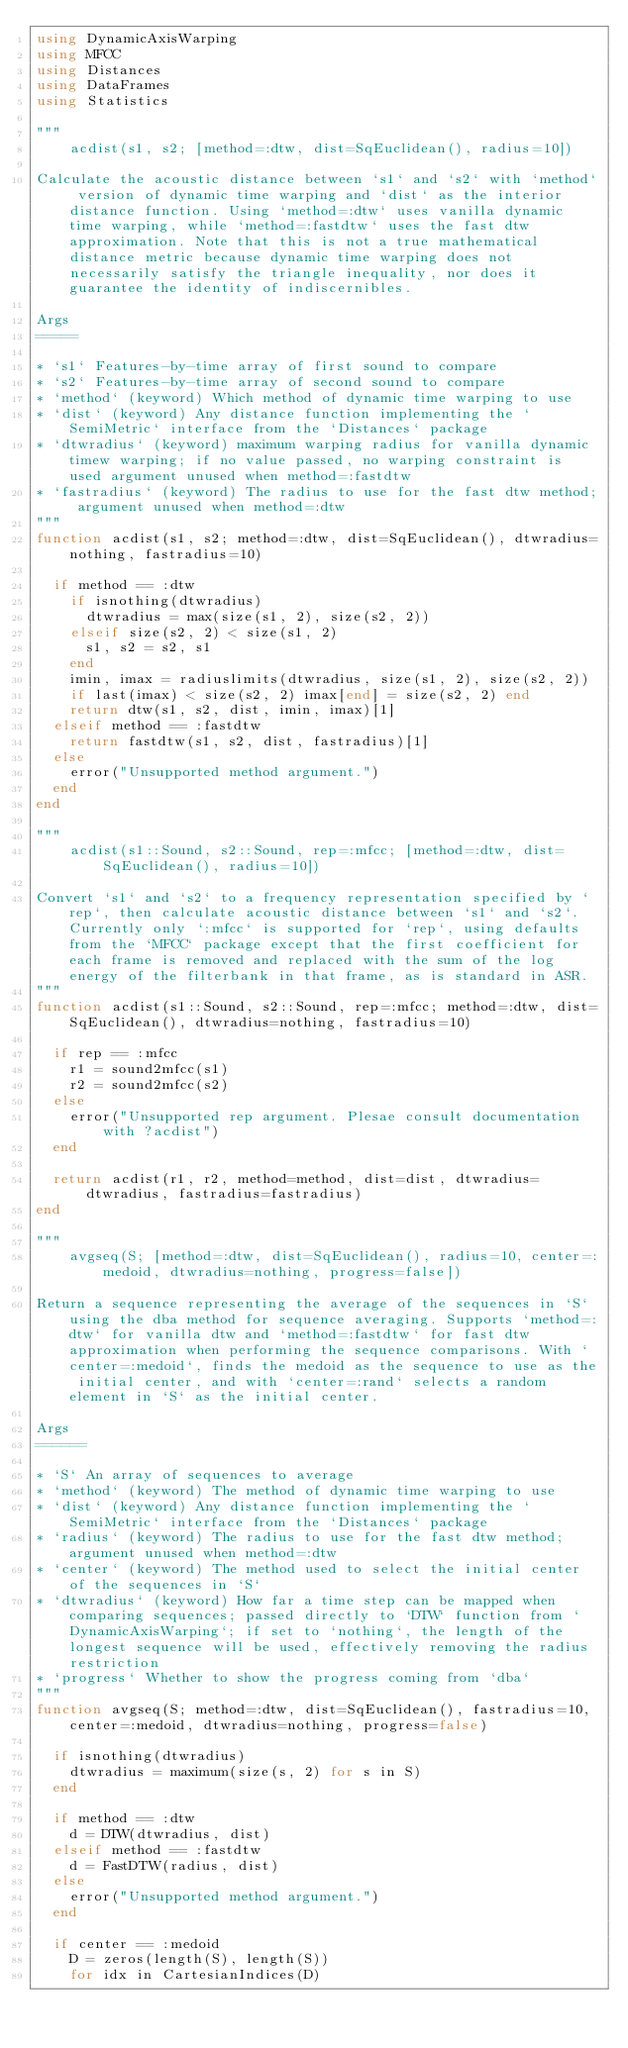<code> <loc_0><loc_0><loc_500><loc_500><_Julia_>using DynamicAxisWarping
using MFCC
using Distances
using DataFrames
using Statistics

"""
    acdist(s1, s2; [method=:dtw, dist=SqEuclidean(), radius=10])

Calculate the acoustic distance between `s1` and `s2` with `method` version of dynamic time warping and `dist` as the interior distance function. Using `method=:dtw` uses vanilla dynamic time warping, while `method=:fastdtw` uses the fast dtw approximation. Note that this is not a true mathematical distance metric because dynamic time warping does not necessarily satisfy the triangle inequality, nor does it guarantee the identity of indiscernibles.

Args
=====

* `s1` Features-by-time array of first sound to compare
* `s2` Features-by-time array of second sound to compare
* `method` (keyword) Which method of dynamic time warping to use
* `dist` (keyword) Any distance function implementing the `SemiMetric` interface from the `Distances` package
* `dtwradius` (keyword) maximum warping radius for vanilla dynamic timew warping; if no value passed, no warping constraint is used argument unused when method=:fastdtw
* `fastradius` (keyword) The radius to use for the fast dtw method; argument unused when method=:dtw
"""
function acdist(s1, s2; method=:dtw, dist=SqEuclidean(), dtwradius=nothing, fastradius=10)
  
  if method == :dtw
    if isnothing(dtwradius)
      dtwradius = max(size(s1, 2), size(s2, 2))
    elseif size(s2, 2) < size(s1, 2)
      s1, s2 = s2, s1
    end
    imin, imax = radiuslimits(dtwradius, size(s1, 2), size(s2, 2))
    if last(imax) < size(s2, 2) imax[end] = size(s2, 2) end
    return dtw(s1, s2, dist, imin, imax)[1]
  elseif method == :fastdtw
    return fastdtw(s1, s2, dist, fastradius)[1]
  else
    error("Unsupported method argument.")
  end
end

"""
    acdist(s1::Sound, s2::Sound, rep=:mfcc; [method=:dtw, dist=SqEuclidean(), radius=10])

Convert `s1` and `s2` to a frequency representation specified by `rep`, then calculate acoustic distance between `s1` and `s2`. Currently only `:mfcc` is supported for `rep`, using defaults from the `MFCC` package except that the first coefficient for each frame is removed and replaced with the sum of the log energy of the filterbank in that frame, as is standard in ASR.
"""
function acdist(s1::Sound, s2::Sound, rep=:mfcc; method=:dtw, dist=SqEuclidean(), dtwradius=nothing, fastradius=10)

  if rep == :mfcc
    r1 = sound2mfcc(s1)
    r2 = sound2mfcc(s2)
  else
    error("Unsupported rep argument. Plesae consult documentation with ?acdist")
  end

  return acdist(r1, r2, method=method, dist=dist, dtwradius=dtwradius, fastradius=fastradius)
end

"""
    avgseq(S; [method=:dtw, dist=SqEuclidean(), radius=10, center=:medoid, dtwradius=nothing, progress=false])

Return a sequence representing the average of the sequences in `S` using the dba method for sequence averaging. Supports `method=:dtw` for vanilla dtw and `method=:fastdtw` for fast dtw approximation when performing the sequence comparisons. With `center=:medoid`, finds the medoid as the sequence to use as the initial center, and with `center=:rand` selects a random element in `S` as the initial center.

Args
======

* `S` An array of sequences to average
* `method` (keyword) The method of dynamic time warping to use
* `dist` (keyword) Any distance function implementing the `SemiMetric` interface from the `Distances` package
* `radius` (keyword) The radius to use for the fast dtw method; argument unused when method=:dtw
* `center` (keyword) The method used to select the initial center of the sequences in `S`
* `dtwradius` (keyword) How far a time step can be mapped when comparing sequences; passed directly to `DTW` function from `DynamicAxisWarping`; if set to `nothing`, the length of the longest sequence will be used, effectively removing the radius restriction
* `progress` Whether to show the progress coming from `dba`
"""
function avgseq(S; method=:dtw, dist=SqEuclidean(), fastradius=10, center=:medoid, dtwradius=nothing, progress=false)

  if isnothing(dtwradius)
    dtwradius = maximum(size(s, 2) for s in S)
  end

  if method == :dtw
    d = DTW(dtwradius, dist)
  elseif method == :fastdtw
    d = FastDTW(radius, dist)
  else
    error("Unsupported method argument.")
  end

  if center == :medoid
    D = zeros(length(S), length(S))
    for idx in CartesianIndices(D)</code> 